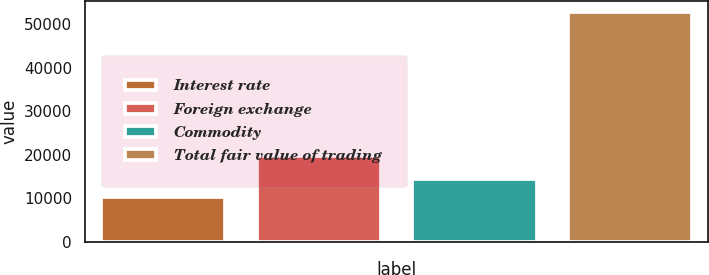Convert chart. <chart><loc_0><loc_0><loc_500><loc_500><bar_chart><fcel>Interest rate<fcel>Foreign exchange<fcel>Commodity<fcel>Total fair value of trading<nl><fcel>10221<fcel>19769<fcel>14477.9<fcel>52790<nl></chart> 